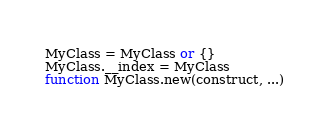Convert code to text. <code><loc_0><loc_0><loc_500><loc_500><_Lua_>MyClass = MyClass or {}
MyClass.__index = MyClass
function MyClass.new(construct, ...)</code> 